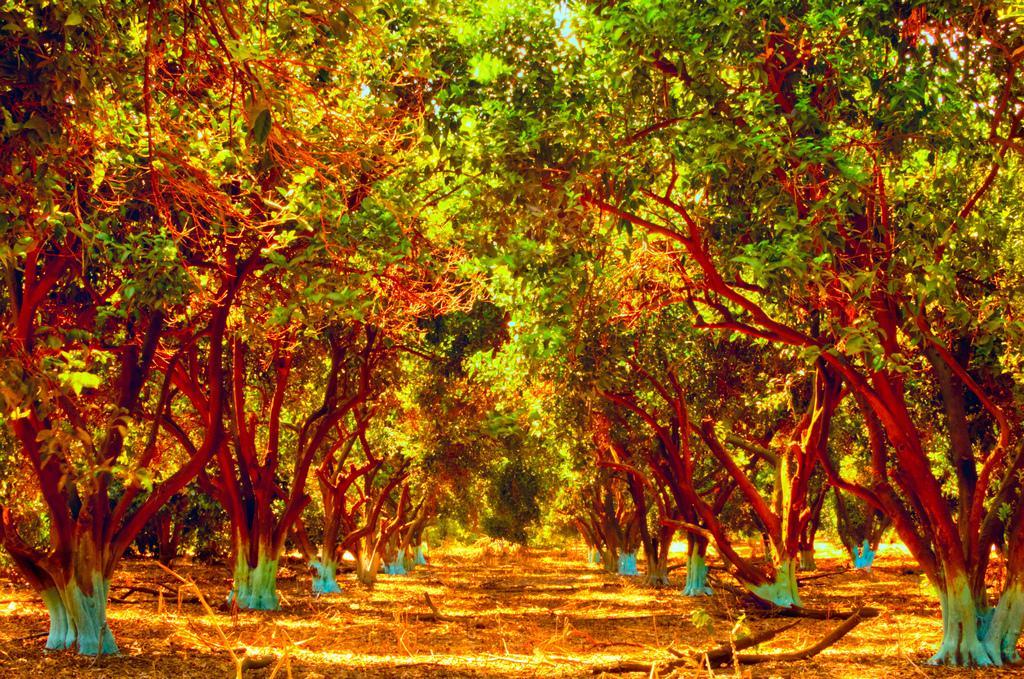Can you describe this image briefly? In the picture we can see a path with full of dried leaves and trees. 